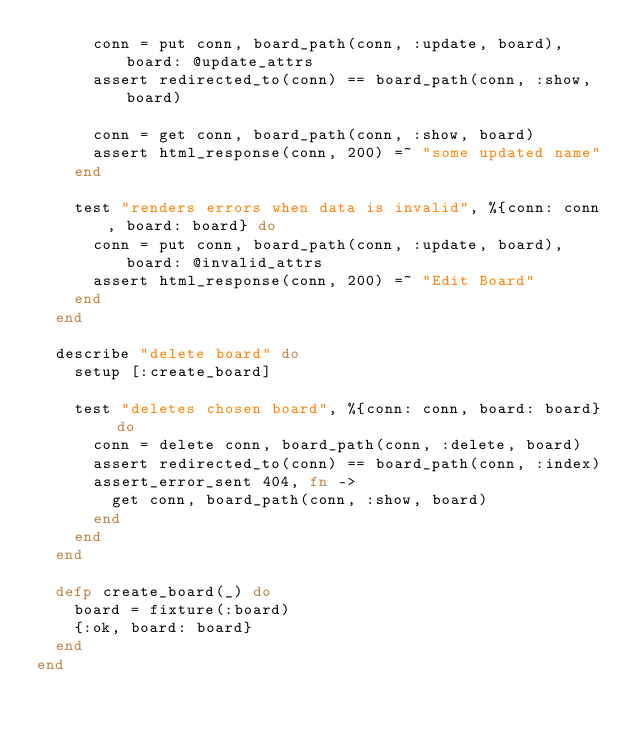Convert code to text. <code><loc_0><loc_0><loc_500><loc_500><_Elixir_>      conn = put conn, board_path(conn, :update, board), board: @update_attrs
      assert redirected_to(conn) == board_path(conn, :show, board)

      conn = get conn, board_path(conn, :show, board)
      assert html_response(conn, 200) =~ "some updated name"
    end

    test "renders errors when data is invalid", %{conn: conn, board: board} do
      conn = put conn, board_path(conn, :update, board), board: @invalid_attrs
      assert html_response(conn, 200) =~ "Edit Board"
    end
  end

  describe "delete board" do
    setup [:create_board]

    test "deletes chosen board", %{conn: conn, board: board} do
      conn = delete conn, board_path(conn, :delete, board)
      assert redirected_to(conn) == board_path(conn, :index)
      assert_error_sent 404, fn ->
        get conn, board_path(conn, :show, board)
      end
    end
  end

  defp create_board(_) do
    board = fixture(:board)
    {:ok, board: board}
  end
end
</code> 